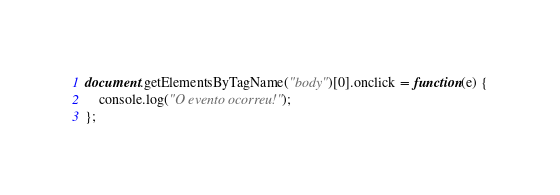<code> <loc_0><loc_0><loc_500><loc_500><_JavaScript_>document.getElementsByTagName("body")[0].onclick = function(e) {
    console.log("O evento ocorreu!");
};</code> 